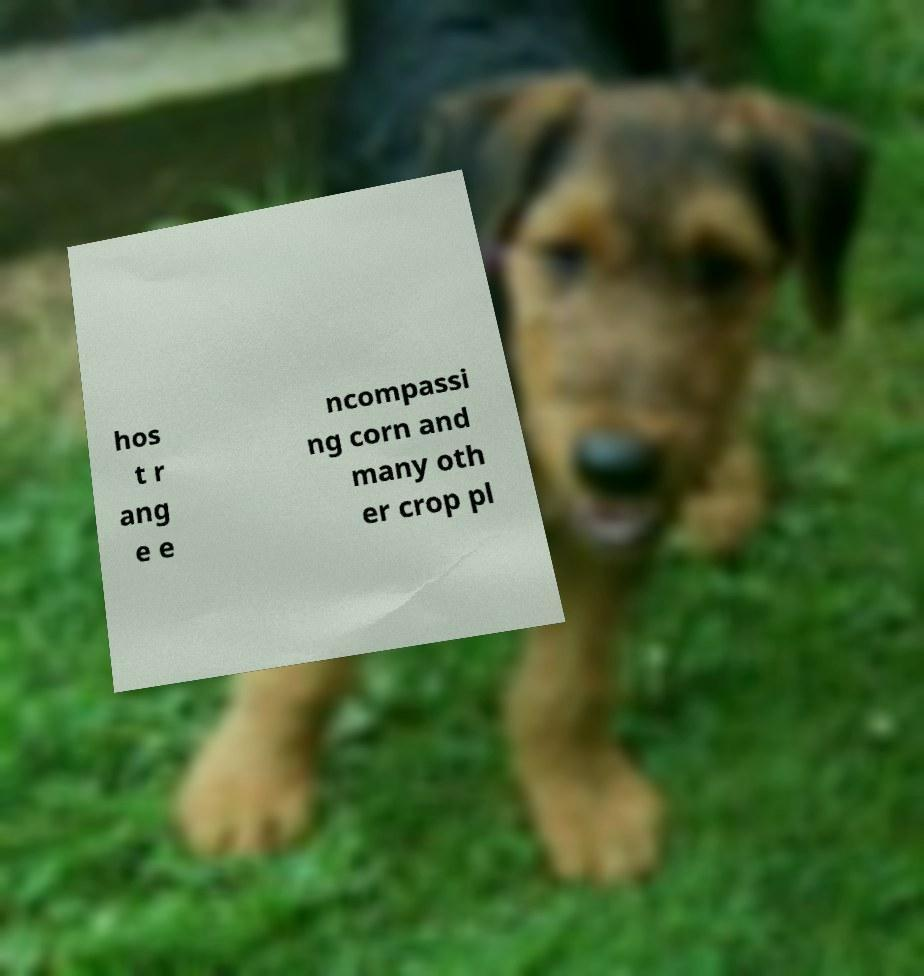For documentation purposes, I need the text within this image transcribed. Could you provide that? hos t r ang e e ncompassi ng corn and many oth er crop pl 